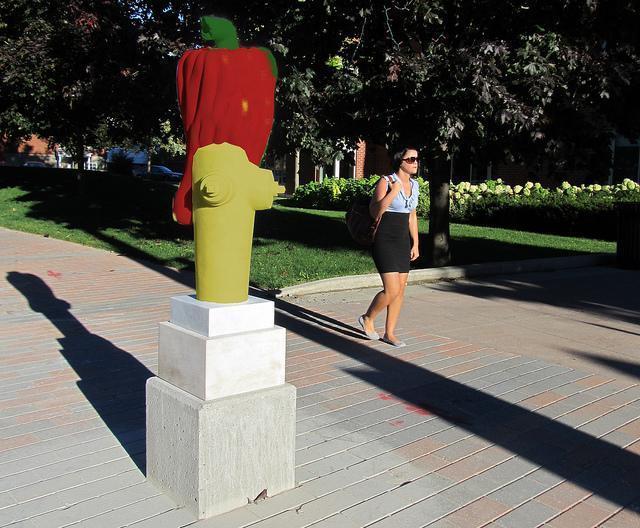How many poles surround the fire hydrant?
Give a very brief answer. 0. How many news anchors are on the television screen?
Give a very brief answer. 0. 